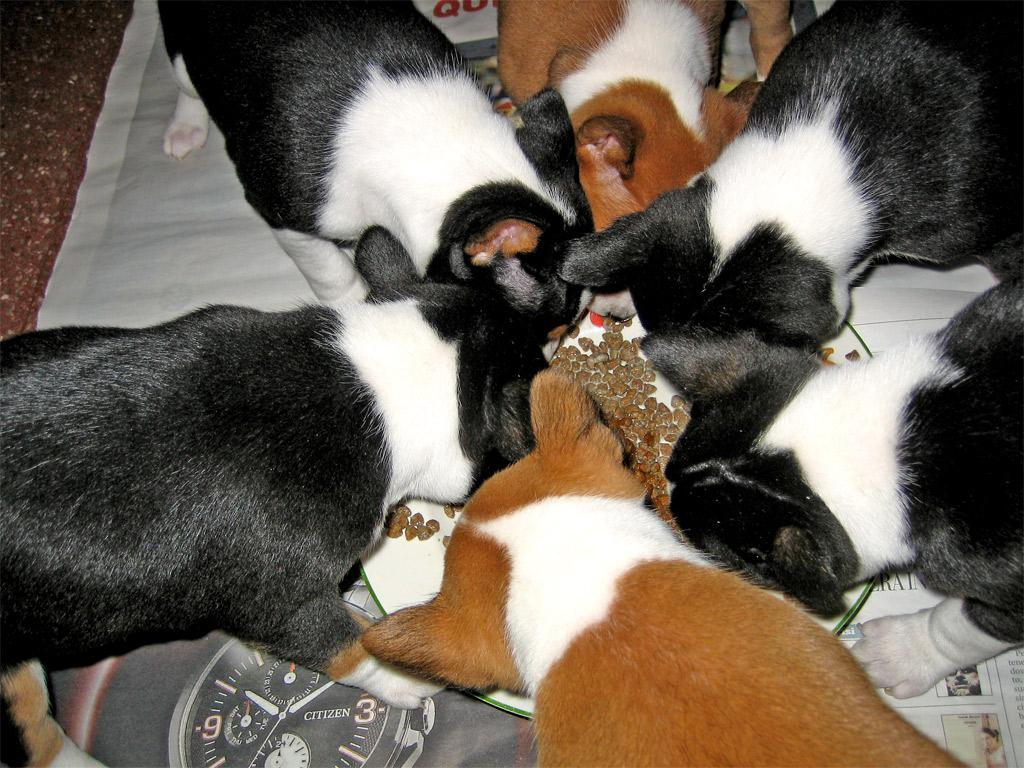What animals are present in the image? There are dogs in the image. What are the dogs doing in the image? The dogs are eating food. How many girls are playing the horn in the image? There are no girls or horns present in the image; it features dogs eating food. 